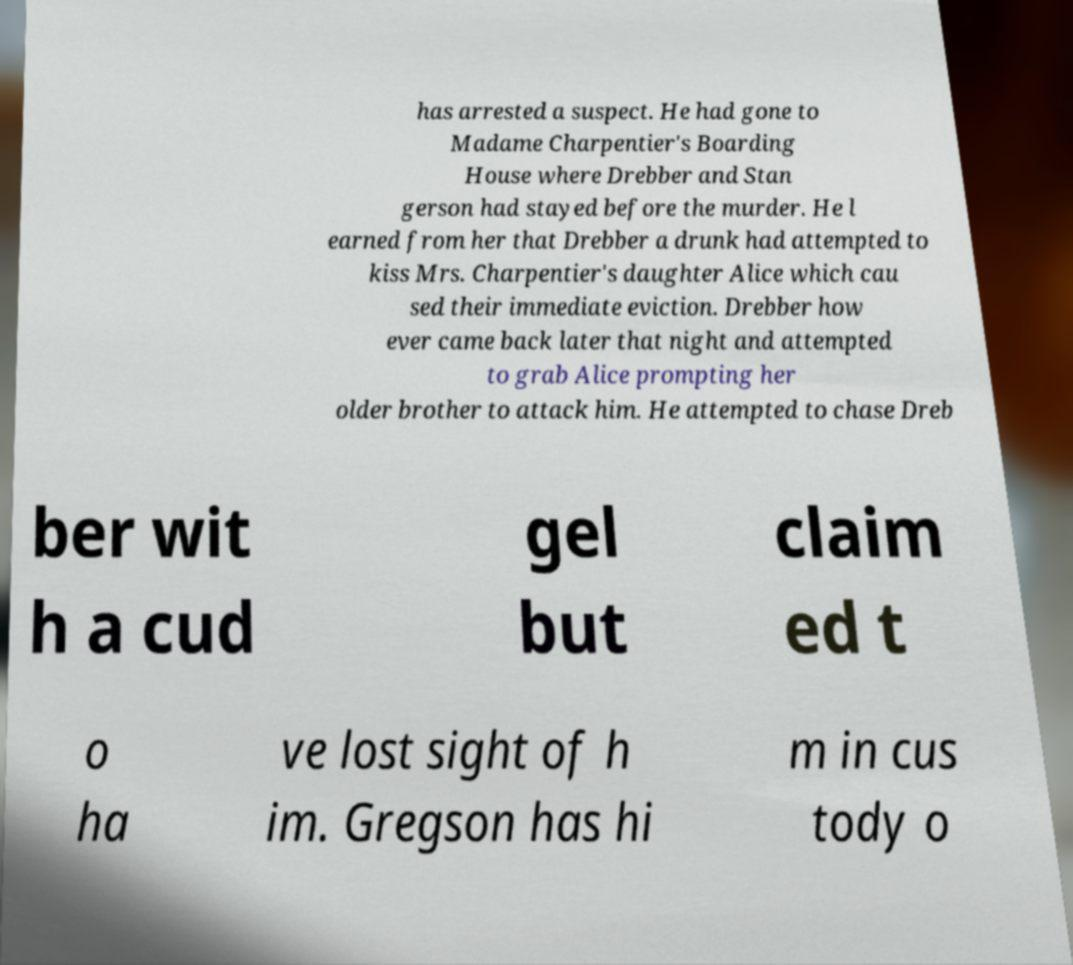Can you read and provide the text displayed in the image?This photo seems to have some interesting text. Can you extract and type it out for me? has arrested a suspect. He had gone to Madame Charpentier's Boarding House where Drebber and Stan gerson had stayed before the murder. He l earned from her that Drebber a drunk had attempted to kiss Mrs. Charpentier's daughter Alice which cau sed their immediate eviction. Drebber how ever came back later that night and attempted to grab Alice prompting her older brother to attack him. He attempted to chase Dreb ber wit h a cud gel but claim ed t o ha ve lost sight of h im. Gregson has hi m in cus tody o 